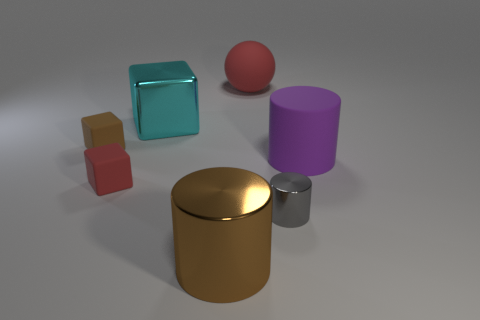Add 1 small cyan matte objects. How many objects exist? 8 Subtract all big cylinders. How many cylinders are left? 1 Subtract 1 blocks. How many blocks are left? 2 Subtract all cylinders. How many objects are left? 4 Add 7 large brown cylinders. How many large brown cylinders are left? 8 Add 4 spheres. How many spheres exist? 5 Subtract 0 yellow cylinders. How many objects are left? 7 Subtract all large metallic blocks. Subtract all cyan objects. How many objects are left? 5 